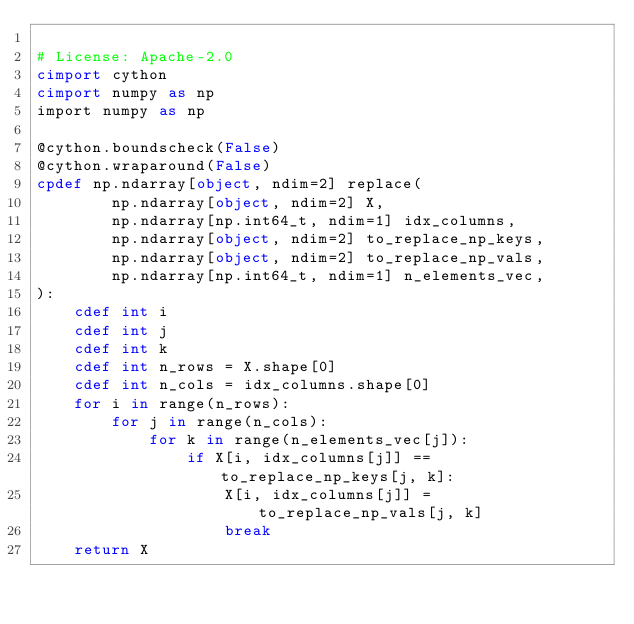<code> <loc_0><loc_0><loc_500><loc_500><_Cython_>
# License: Apache-2.0
cimport cython
cimport numpy as np
import numpy as np

@cython.boundscheck(False)
@cython.wraparound(False)
cpdef np.ndarray[object, ndim=2] replace(
        np.ndarray[object, ndim=2] X,
        np.ndarray[np.int64_t, ndim=1] idx_columns,
        np.ndarray[object, ndim=2] to_replace_np_keys,
        np.ndarray[object, ndim=2] to_replace_np_vals,
        np.ndarray[np.int64_t, ndim=1] n_elements_vec,
):
    cdef int i
    cdef int j
    cdef int k
    cdef int n_rows = X.shape[0]
    cdef int n_cols = idx_columns.shape[0]
    for i in range(n_rows):
        for j in range(n_cols):
            for k in range(n_elements_vec[j]):
                if X[i, idx_columns[j]] == to_replace_np_keys[j, k]:
                    X[i, idx_columns[j]] = to_replace_np_vals[j, k]
                    break
    return X</code> 